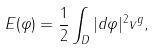Convert formula to latex. <formula><loc_0><loc_0><loc_500><loc_500>E ( \varphi ) = \frac { 1 } { 2 } \int _ { D } | d \varphi | ^ { 2 } v ^ { g } ,</formula> 